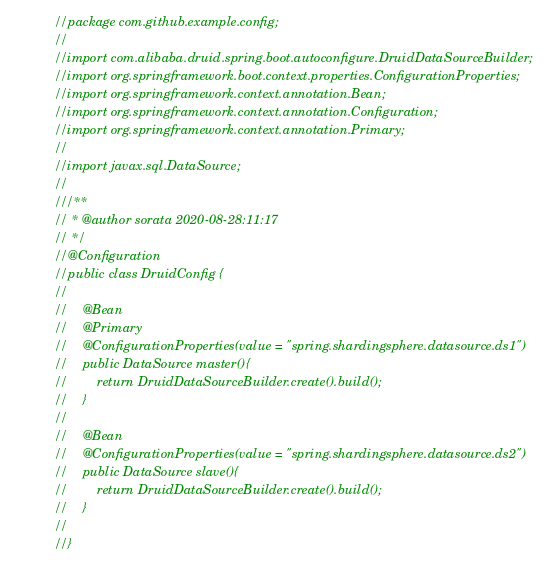Convert code to text. <code><loc_0><loc_0><loc_500><loc_500><_Java_>//package com.github.example.config;
//
//import com.alibaba.druid.spring.boot.autoconfigure.DruidDataSourceBuilder;
//import org.springframework.boot.context.properties.ConfigurationProperties;
//import org.springframework.context.annotation.Bean;
//import org.springframework.context.annotation.Configuration;
//import org.springframework.context.annotation.Primary;
//
//import javax.sql.DataSource;
//
///**
// * @author sorata 2020-08-28:11:17
// */
//@Configuration
//public class DruidConfig {
//
//    @Bean
//    @Primary
//    @ConfigurationProperties(value = "spring.shardingsphere.datasource.ds1")
//    public DataSource master(){
//        return DruidDataSourceBuilder.create().build();
//    }
//
//    @Bean
//    @ConfigurationProperties(value = "spring.shardingsphere.datasource.ds2")
//    public DataSource slave(){
//        return DruidDataSourceBuilder.create().build();
//    }
//
//}
</code> 